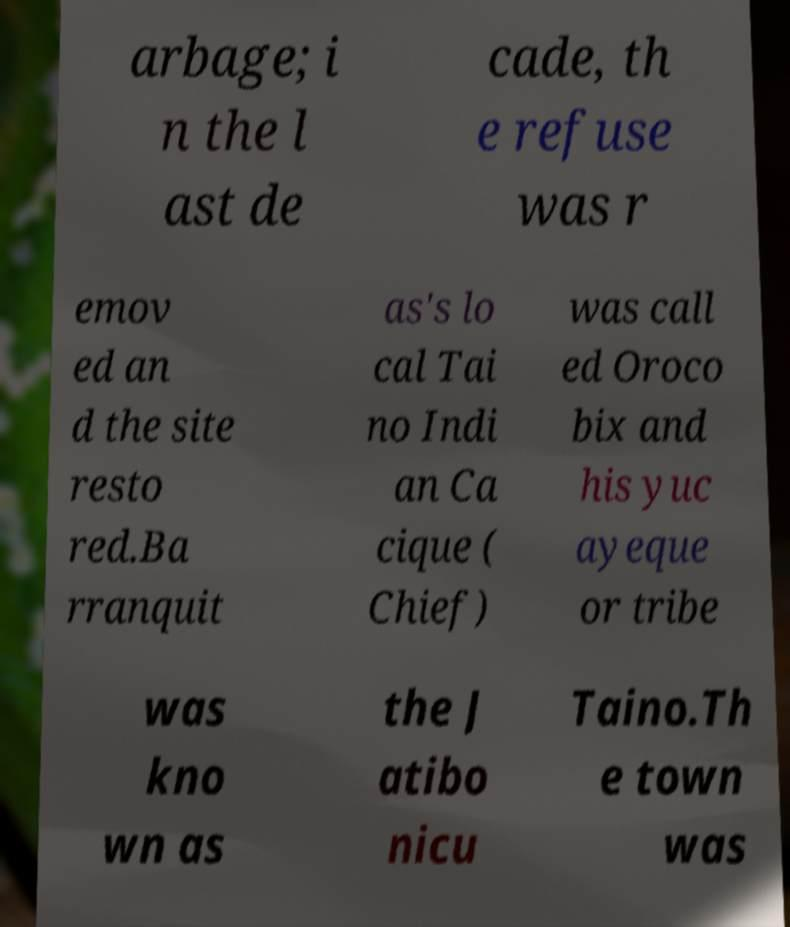Could you extract and type out the text from this image? arbage; i n the l ast de cade, th e refuse was r emov ed an d the site resto red.Ba rranquit as's lo cal Tai no Indi an Ca cique ( Chief) was call ed Oroco bix and his yuc ayeque or tribe was kno wn as the J atibo nicu Taino.Th e town was 